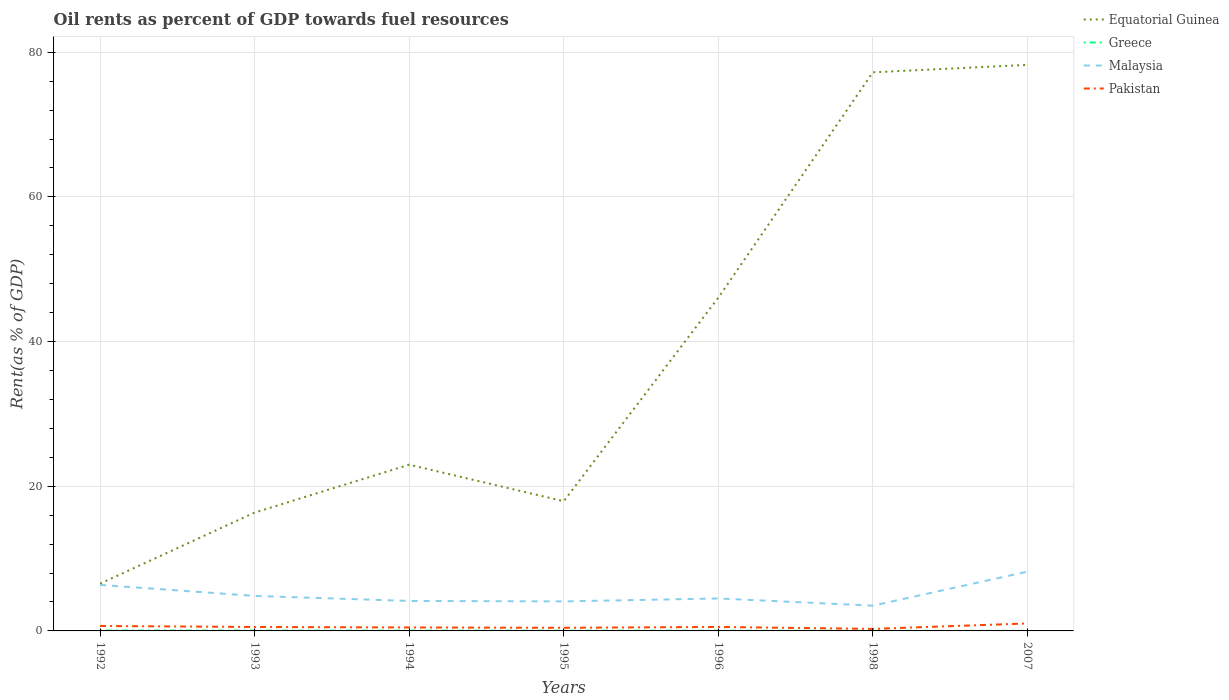Does the line corresponding to Malaysia intersect with the line corresponding to Equatorial Guinea?
Your response must be concise. No. Is the number of lines equal to the number of legend labels?
Make the answer very short. Yes. Across all years, what is the maximum oil rent in Equatorial Guinea?
Offer a terse response. 6.54. What is the total oil rent in Malaysia in the graph?
Your response must be concise. 1.52. What is the difference between the highest and the second highest oil rent in Greece?
Provide a succinct answer. 0.05. How many lines are there?
Provide a short and direct response. 4. Are the values on the major ticks of Y-axis written in scientific E-notation?
Offer a terse response. No. Does the graph contain any zero values?
Your answer should be very brief. No. Does the graph contain grids?
Ensure brevity in your answer.  Yes. Where does the legend appear in the graph?
Your answer should be very brief. Top right. How many legend labels are there?
Keep it short and to the point. 4. What is the title of the graph?
Keep it short and to the point. Oil rents as percent of GDP towards fuel resources. What is the label or title of the X-axis?
Your answer should be very brief. Years. What is the label or title of the Y-axis?
Provide a short and direct response. Rent(as % of GDP). What is the Rent(as % of GDP) in Equatorial Guinea in 1992?
Offer a very short reply. 6.54. What is the Rent(as % of GDP) in Greece in 1992?
Your answer should be very brief. 0.06. What is the Rent(as % of GDP) of Malaysia in 1992?
Provide a succinct answer. 6.36. What is the Rent(as % of GDP) of Pakistan in 1992?
Give a very brief answer. 0.68. What is the Rent(as % of GDP) of Equatorial Guinea in 1993?
Give a very brief answer. 16.36. What is the Rent(as % of GDP) of Greece in 1993?
Your answer should be very brief. 0.05. What is the Rent(as % of GDP) in Malaysia in 1993?
Offer a very short reply. 4.84. What is the Rent(as % of GDP) of Pakistan in 1993?
Give a very brief answer. 0.55. What is the Rent(as % of GDP) in Equatorial Guinea in 1994?
Your answer should be compact. 22.98. What is the Rent(as % of GDP) of Greece in 1994?
Give a very brief answer. 0.04. What is the Rent(as % of GDP) in Malaysia in 1994?
Give a very brief answer. 4.15. What is the Rent(as % of GDP) of Pakistan in 1994?
Offer a very short reply. 0.48. What is the Rent(as % of GDP) of Equatorial Guinea in 1995?
Give a very brief answer. 17.93. What is the Rent(as % of GDP) of Greece in 1995?
Provide a short and direct response. 0.03. What is the Rent(as % of GDP) in Malaysia in 1995?
Give a very brief answer. 4.08. What is the Rent(as % of GDP) of Pakistan in 1995?
Provide a short and direct response. 0.43. What is the Rent(as % of GDP) of Equatorial Guinea in 1996?
Your response must be concise. 46.07. What is the Rent(as % of GDP) in Greece in 1996?
Your answer should be very brief. 0.03. What is the Rent(as % of GDP) of Malaysia in 1996?
Keep it short and to the point. 4.49. What is the Rent(as % of GDP) of Pakistan in 1996?
Provide a succinct answer. 0.55. What is the Rent(as % of GDP) in Equatorial Guinea in 1998?
Offer a very short reply. 77.23. What is the Rent(as % of GDP) of Greece in 1998?
Make the answer very short. 0.01. What is the Rent(as % of GDP) in Malaysia in 1998?
Your answer should be very brief. 3.49. What is the Rent(as % of GDP) in Pakistan in 1998?
Offer a very short reply. 0.28. What is the Rent(as % of GDP) in Equatorial Guinea in 2007?
Provide a succinct answer. 78.25. What is the Rent(as % of GDP) in Greece in 2007?
Your answer should be very brief. 0.01. What is the Rent(as % of GDP) in Malaysia in 2007?
Make the answer very short. 8.19. What is the Rent(as % of GDP) of Pakistan in 2007?
Your response must be concise. 1.03. Across all years, what is the maximum Rent(as % of GDP) of Equatorial Guinea?
Ensure brevity in your answer.  78.25. Across all years, what is the maximum Rent(as % of GDP) of Greece?
Keep it short and to the point. 0.06. Across all years, what is the maximum Rent(as % of GDP) of Malaysia?
Your answer should be very brief. 8.19. Across all years, what is the maximum Rent(as % of GDP) of Pakistan?
Make the answer very short. 1.03. Across all years, what is the minimum Rent(as % of GDP) of Equatorial Guinea?
Give a very brief answer. 6.54. Across all years, what is the minimum Rent(as % of GDP) of Greece?
Offer a terse response. 0.01. Across all years, what is the minimum Rent(as % of GDP) in Malaysia?
Your answer should be compact. 3.49. Across all years, what is the minimum Rent(as % of GDP) of Pakistan?
Provide a succinct answer. 0.28. What is the total Rent(as % of GDP) of Equatorial Guinea in the graph?
Provide a short and direct response. 265.36. What is the total Rent(as % of GDP) in Greece in the graph?
Provide a succinct answer. 0.23. What is the total Rent(as % of GDP) in Malaysia in the graph?
Your answer should be compact. 35.6. What is the total Rent(as % of GDP) in Pakistan in the graph?
Your response must be concise. 4.01. What is the difference between the Rent(as % of GDP) of Equatorial Guinea in 1992 and that in 1993?
Make the answer very short. -9.83. What is the difference between the Rent(as % of GDP) of Greece in 1992 and that in 1993?
Keep it short and to the point. 0.01. What is the difference between the Rent(as % of GDP) in Malaysia in 1992 and that in 1993?
Your answer should be compact. 1.52. What is the difference between the Rent(as % of GDP) of Pakistan in 1992 and that in 1993?
Provide a short and direct response. 0.14. What is the difference between the Rent(as % of GDP) in Equatorial Guinea in 1992 and that in 1994?
Your answer should be compact. -16.44. What is the difference between the Rent(as % of GDP) of Greece in 1992 and that in 1994?
Make the answer very short. 0.02. What is the difference between the Rent(as % of GDP) of Malaysia in 1992 and that in 1994?
Offer a very short reply. 2.22. What is the difference between the Rent(as % of GDP) in Pakistan in 1992 and that in 1994?
Make the answer very short. 0.2. What is the difference between the Rent(as % of GDP) in Equatorial Guinea in 1992 and that in 1995?
Your answer should be compact. -11.39. What is the difference between the Rent(as % of GDP) of Greece in 1992 and that in 1995?
Ensure brevity in your answer.  0.03. What is the difference between the Rent(as % of GDP) of Malaysia in 1992 and that in 1995?
Offer a terse response. 2.28. What is the difference between the Rent(as % of GDP) in Pakistan in 1992 and that in 1995?
Offer a very short reply. 0.25. What is the difference between the Rent(as % of GDP) of Equatorial Guinea in 1992 and that in 1996?
Your answer should be compact. -39.53. What is the difference between the Rent(as % of GDP) in Greece in 1992 and that in 1996?
Provide a short and direct response. 0.03. What is the difference between the Rent(as % of GDP) in Malaysia in 1992 and that in 1996?
Keep it short and to the point. 1.88. What is the difference between the Rent(as % of GDP) in Pakistan in 1992 and that in 1996?
Provide a short and direct response. 0.13. What is the difference between the Rent(as % of GDP) in Equatorial Guinea in 1992 and that in 1998?
Provide a succinct answer. -70.69. What is the difference between the Rent(as % of GDP) of Greece in 1992 and that in 1998?
Your answer should be compact. 0.05. What is the difference between the Rent(as % of GDP) in Malaysia in 1992 and that in 1998?
Keep it short and to the point. 2.87. What is the difference between the Rent(as % of GDP) in Pakistan in 1992 and that in 1998?
Offer a very short reply. 0.4. What is the difference between the Rent(as % of GDP) in Equatorial Guinea in 1992 and that in 2007?
Your answer should be very brief. -71.72. What is the difference between the Rent(as % of GDP) of Greece in 1992 and that in 2007?
Keep it short and to the point. 0.05. What is the difference between the Rent(as % of GDP) of Malaysia in 1992 and that in 2007?
Your answer should be compact. -1.83. What is the difference between the Rent(as % of GDP) in Pakistan in 1992 and that in 2007?
Your answer should be compact. -0.35. What is the difference between the Rent(as % of GDP) in Equatorial Guinea in 1993 and that in 1994?
Your response must be concise. -6.62. What is the difference between the Rent(as % of GDP) of Greece in 1993 and that in 1994?
Provide a short and direct response. 0.01. What is the difference between the Rent(as % of GDP) in Malaysia in 1993 and that in 1994?
Provide a short and direct response. 0.69. What is the difference between the Rent(as % of GDP) in Pakistan in 1993 and that in 1994?
Give a very brief answer. 0.07. What is the difference between the Rent(as % of GDP) of Equatorial Guinea in 1993 and that in 1995?
Give a very brief answer. -1.57. What is the difference between the Rent(as % of GDP) of Greece in 1993 and that in 1995?
Keep it short and to the point. 0.01. What is the difference between the Rent(as % of GDP) in Malaysia in 1993 and that in 1995?
Your response must be concise. 0.76. What is the difference between the Rent(as % of GDP) in Pakistan in 1993 and that in 1995?
Offer a terse response. 0.11. What is the difference between the Rent(as % of GDP) of Equatorial Guinea in 1993 and that in 1996?
Provide a short and direct response. -29.7. What is the difference between the Rent(as % of GDP) in Greece in 1993 and that in 1996?
Offer a very short reply. 0.01. What is the difference between the Rent(as % of GDP) in Malaysia in 1993 and that in 1996?
Ensure brevity in your answer.  0.35. What is the difference between the Rent(as % of GDP) in Pakistan in 1993 and that in 1996?
Your response must be concise. -0. What is the difference between the Rent(as % of GDP) in Equatorial Guinea in 1993 and that in 1998?
Your answer should be compact. -60.86. What is the difference between the Rent(as % of GDP) of Greece in 1993 and that in 1998?
Provide a short and direct response. 0.03. What is the difference between the Rent(as % of GDP) in Malaysia in 1993 and that in 1998?
Offer a very short reply. 1.35. What is the difference between the Rent(as % of GDP) of Pakistan in 1993 and that in 1998?
Provide a short and direct response. 0.27. What is the difference between the Rent(as % of GDP) in Equatorial Guinea in 1993 and that in 2007?
Your answer should be very brief. -61.89. What is the difference between the Rent(as % of GDP) of Greece in 1993 and that in 2007?
Make the answer very short. 0.04. What is the difference between the Rent(as % of GDP) of Malaysia in 1993 and that in 2007?
Your answer should be very brief. -3.36. What is the difference between the Rent(as % of GDP) of Pakistan in 1993 and that in 2007?
Ensure brevity in your answer.  -0.49. What is the difference between the Rent(as % of GDP) in Equatorial Guinea in 1994 and that in 1995?
Offer a very short reply. 5.05. What is the difference between the Rent(as % of GDP) in Greece in 1994 and that in 1995?
Your response must be concise. 0.01. What is the difference between the Rent(as % of GDP) of Malaysia in 1994 and that in 1995?
Your response must be concise. 0.07. What is the difference between the Rent(as % of GDP) of Pakistan in 1994 and that in 1995?
Give a very brief answer. 0.04. What is the difference between the Rent(as % of GDP) of Equatorial Guinea in 1994 and that in 1996?
Your response must be concise. -23.08. What is the difference between the Rent(as % of GDP) of Greece in 1994 and that in 1996?
Your answer should be very brief. 0.01. What is the difference between the Rent(as % of GDP) in Malaysia in 1994 and that in 1996?
Provide a short and direct response. -0.34. What is the difference between the Rent(as % of GDP) of Pakistan in 1994 and that in 1996?
Offer a terse response. -0.07. What is the difference between the Rent(as % of GDP) in Equatorial Guinea in 1994 and that in 1998?
Provide a succinct answer. -54.25. What is the difference between the Rent(as % of GDP) of Greece in 1994 and that in 1998?
Make the answer very short. 0.02. What is the difference between the Rent(as % of GDP) of Malaysia in 1994 and that in 1998?
Your answer should be compact. 0.65. What is the difference between the Rent(as % of GDP) of Pakistan in 1994 and that in 1998?
Your answer should be very brief. 0.2. What is the difference between the Rent(as % of GDP) of Equatorial Guinea in 1994 and that in 2007?
Provide a succinct answer. -55.27. What is the difference between the Rent(as % of GDP) in Greece in 1994 and that in 2007?
Your answer should be compact. 0.03. What is the difference between the Rent(as % of GDP) in Malaysia in 1994 and that in 2007?
Your answer should be very brief. -4.05. What is the difference between the Rent(as % of GDP) in Pakistan in 1994 and that in 2007?
Your answer should be very brief. -0.56. What is the difference between the Rent(as % of GDP) of Equatorial Guinea in 1995 and that in 1996?
Provide a short and direct response. -28.14. What is the difference between the Rent(as % of GDP) of Greece in 1995 and that in 1996?
Offer a very short reply. -0. What is the difference between the Rent(as % of GDP) of Malaysia in 1995 and that in 1996?
Ensure brevity in your answer.  -0.41. What is the difference between the Rent(as % of GDP) of Pakistan in 1995 and that in 1996?
Your answer should be compact. -0.12. What is the difference between the Rent(as % of GDP) of Equatorial Guinea in 1995 and that in 1998?
Provide a succinct answer. -59.3. What is the difference between the Rent(as % of GDP) of Greece in 1995 and that in 1998?
Offer a very short reply. 0.02. What is the difference between the Rent(as % of GDP) of Malaysia in 1995 and that in 1998?
Provide a succinct answer. 0.59. What is the difference between the Rent(as % of GDP) of Pakistan in 1995 and that in 1998?
Your response must be concise. 0.16. What is the difference between the Rent(as % of GDP) in Equatorial Guinea in 1995 and that in 2007?
Offer a terse response. -60.32. What is the difference between the Rent(as % of GDP) in Greece in 1995 and that in 2007?
Your answer should be very brief. 0.02. What is the difference between the Rent(as % of GDP) in Malaysia in 1995 and that in 2007?
Provide a short and direct response. -4.11. What is the difference between the Rent(as % of GDP) in Pakistan in 1995 and that in 2007?
Offer a terse response. -0.6. What is the difference between the Rent(as % of GDP) of Equatorial Guinea in 1996 and that in 1998?
Your response must be concise. -31.16. What is the difference between the Rent(as % of GDP) of Greece in 1996 and that in 1998?
Provide a succinct answer. 0.02. What is the difference between the Rent(as % of GDP) of Pakistan in 1996 and that in 1998?
Ensure brevity in your answer.  0.27. What is the difference between the Rent(as % of GDP) in Equatorial Guinea in 1996 and that in 2007?
Offer a very short reply. -32.19. What is the difference between the Rent(as % of GDP) of Greece in 1996 and that in 2007?
Provide a succinct answer. 0.02. What is the difference between the Rent(as % of GDP) in Malaysia in 1996 and that in 2007?
Your answer should be very brief. -3.71. What is the difference between the Rent(as % of GDP) of Pakistan in 1996 and that in 2007?
Make the answer very short. -0.48. What is the difference between the Rent(as % of GDP) in Equatorial Guinea in 1998 and that in 2007?
Your response must be concise. -1.03. What is the difference between the Rent(as % of GDP) in Greece in 1998 and that in 2007?
Provide a succinct answer. 0. What is the difference between the Rent(as % of GDP) in Malaysia in 1998 and that in 2007?
Offer a terse response. -4.7. What is the difference between the Rent(as % of GDP) in Pakistan in 1998 and that in 2007?
Your response must be concise. -0.76. What is the difference between the Rent(as % of GDP) in Equatorial Guinea in 1992 and the Rent(as % of GDP) in Greece in 1993?
Keep it short and to the point. 6.49. What is the difference between the Rent(as % of GDP) of Equatorial Guinea in 1992 and the Rent(as % of GDP) of Malaysia in 1993?
Offer a very short reply. 1.7. What is the difference between the Rent(as % of GDP) of Equatorial Guinea in 1992 and the Rent(as % of GDP) of Pakistan in 1993?
Your answer should be very brief. 5.99. What is the difference between the Rent(as % of GDP) in Greece in 1992 and the Rent(as % of GDP) in Malaysia in 1993?
Provide a short and direct response. -4.78. What is the difference between the Rent(as % of GDP) in Greece in 1992 and the Rent(as % of GDP) in Pakistan in 1993?
Offer a terse response. -0.49. What is the difference between the Rent(as % of GDP) of Malaysia in 1992 and the Rent(as % of GDP) of Pakistan in 1993?
Your answer should be compact. 5.82. What is the difference between the Rent(as % of GDP) in Equatorial Guinea in 1992 and the Rent(as % of GDP) in Greece in 1994?
Ensure brevity in your answer.  6.5. What is the difference between the Rent(as % of GDP) of Equatorial Guinea in 1992 and the Rent(as % of GDP) of Malaysia in 1994?
Provide a short and direct response. 2.39. What is the difference between the Rent(as % of GDP) of Equatorial Guinea in 1992 and the Rent(as % of GDP) of Pakistan in 1994?
Give a very brief answer. 6.06. What is the difference between the Rent(as % of GDP) of Greece in 1992 and the Rent(as % of GDP) of Malaysia in 1994?
Provide a short and direct response. -4.08. What is the difference between the Rent(as % of GDP) in Greece in 1992 and the Rent(as % of GDP) in Pakistan in 1994?
Keep it short and to the point. -0.42. What is the difference between the Rent(as % of GDP) of Malaysia in 1992 and the Rent(as % of GDP) of Pakistan in 1994?
Offer a very short reply. 5.88. What is the difference between the Rent(as % of GDP) of Equatorial Guinea in 1992 and the Rent(as % of GDP) of Greece in 1995?
Make the answer very short. 6.51. What is the difference between the Rent(as % of GDP) in Equatorial Guinea in 1992 and the Rent(as % of GDP) in Malaysia in 1995?
Provide a succinct answer. 2.46. What is the difference between the Rent(as % of GDP) of Equatorial Guinea in 1992 and the Rent(as % of GDP) of Pakistan in 1995?
Offer a very short reply. 6.1. What is the difference between the Rent(as % of GDP) of Greece in 1992 and the Rent(as % of GDP) of Malaysia in 1995?
Make the answer very short. -4.02. What is the difference between the Rent(as % of GDP) in Greece in 1992 and the Rent(as % of GDP) in Pakistan in 1995?
Ensure brevity in your answer.  -0.37. What is the difference between the Rent(as % of GDP) of Malaysia in 1992 and the Rent(as % of GDP) of Pakistan in 1995?
Keep it short and to the point. 5.93. What is the difference between the Rent(as % of GDP) of Equatorial Guinea in 1992 and the Rent(as % of GDP) of Greece in 1996?
Your answer should be very brief. 6.5. What is the difference between the Rent(as % of GDP) in Equatorial Guinea in 1992 and the Rent(as % of GDP) in Malaysia in 1996?
Provide a succinct answer. 2.05. What is the difference between the Rent(as % of GDP) of Equatorial Guinea in 1992 and the Rent(as % of GDP) of Pakistan in 1996?
Provide a succinct answer. 5.99. What is the difference between the Rent(as % of GDP) in Greece in 1992 and the Rent(as % of GDP) in Malaysia in 1996?
Your answer should be very brief. -4.43. What is the difference between the Rent(as % of GDP) of Greece in 1992 and the Rent(as % of GDP) of Pakistan in 1996?
Make the answer very short. -0.49. What is the difference between the Rent(as % of GDP) in Malaysia in 1992 and the Rent(as % of GDP) in Pakistan in 1996?
Provide a succinct answer. 5.81. What is the difference between the Rent(as % of GDP) of Equatorial Guinea in 1992 and the Rent(as % of GDP) of Greece in 1998?
Your response must be concise. 6.52. What is the difference between the Rent(as % of GDP) of Equatorial Guinea in 1992 and the Rent(as % of GDP) of Malaysia in 1998?
Your response must be concise. 3.04. What is the difference between the Rent(as % of GDP) of Equatorial Guinea in 1992 and the Rent(as % of GDP) of Pakistan in 1998?
Your response must be concise. 6.26. What is the difference between the Rent(as % of GDP) in Greece in 1992 and the Rent(as % of GDP) in Malaysia in 1998?
Provide a short and direct response. -3.43. What is the difference between the Rent(as % of GDP) of Greece in 1992 and the Rent(as % of GDP) of Pakistan in 1998?
Give a very brief answer. -0.22. What is the difference between the Rent(as % of GDP) in Malaysia in 1992 and the Rent(as % of GDP) in Pakistan in 1998?
Provide a succinct answer. 6.09. What is the difference between the Rent(as % of GDP) in Equatorial Guinea in 1992 and the Rent(as % of GDP) in Greece in 2007?
Provide a short and direct response. 6.53. What is the difference between the Rent(as % of GDP) in Equatorial Guinea in 1992 and the Rent(as % of GDP) in Malaysia in 2007?
Make the answer very short. -1.66. What is the difference between the Rent(as % of GDP) in Equatorial Guinea in 1992 and the Rent(as % of GDP) in Pakistan in 2007?
Offer a terse response. 5.5. What is the difference between the Rent(as % of GDP) of Greece in 1992 and the Rent(as % of GDP) of Malaysia in 2007?
Your answer should be compact. -8.13. What is the difference between the Rent(as % of GDP) of Greece in 1992 and the Rent(as % of GDP) of Pakistan in 2007?
Offer a very short reply. -0.97. What is the difference between the Rent(as % of GDP) in Malaysia in 1992 and the Rent(as % of GDP) in Pakistan in 2007?
Give a very brief answer. 5.33. What is the difference between the Rent(as % of GDP) in Equatorial Guinea in 1993 and the Rent(as % of GDP) in Greece in 1994?
Ensure brevity in your answer.  16.33. What is the difference between the Rent(as % of GDP) in Equatorial Guinea in 1993 and the Rent(as % of GDP) in Malaysia in 1994?
Provide a short and direct response. 12.22. What is the difference between the Rent(as % of GDP) of Equatorial Guinea in 1993 and the Rent(as % of GDP) of Pakistan in 1994?
Offer a terse response. 15.88. What is the difference between the Rent(as % of GDP) of Greece in 1993 and the Rent(as % of GDP) of Malaysia in 1994?
Provide a succinct answer. -4.1. What is the difference between the Rent(as % of GDP) in Greece in 1993 and the Rent(as % of GDP) in Pakistan in 1994?
Ensure brevity in your answer.  -0.43. What is the difference between the Rent(as % of GDP) in Malaysia in 1993 and the Rent(as % of GDP) in Pakistan in 1994?
Offer a very short reply. 4.36. What is the difference between the Rent(as % of GDP) in Equatorial Guinea in 1993 and the Rent(as % of GDP) in Greece in 1995?
Keep it short and to the point. 16.33. What is the difference between the Rent(as % of GDP) of Equatorial Guinea in 1993 and the Rent(as % of GDP) of Malaysia in 1995?
Provide a succinct answer. 12.28. What is the difference between the Rent(as % of GDP) in Equatorial Guinea in 1993 and the Rent(as % of GDP) in Pakistan in 1995?
Provide a succinct answer. 15.93. What is the difference between the Rent(as % of GDP) of Greece in 1993 and the Rent(as % of GDP) of Malaysia in 1995?
Provide a short and direct response. -4.03. What is the difference between the Rent(as % of GDP) in Greece in 1993 and the Rent(as % of GDP) in Pakistan in 1995?
Provide a succinct answer. -0.39. What is the difference between the Rent(as % of GDP) in Malaysia in 1993 and the Rent(as % of GDP) in Pakistan in 1995?
Offer a terse response. 4.41. What is the difference between the Rent(as % of GDP) in Equatorial Guinea in 1993 and the Rent(as % of GDP) in Greece in 1996?
Make the answer very short. 16.33. What is the difference between the Rent(as % of GDP) of Equatorial Guinea in 1993 and the Rent(as % of GDP) of Malaysia in 1996?
Give a very brief answer. 11.87. What is the difference between the Rent(as % of GDP) in Equatorial Guinea in 1993 and the Rent(as % of GDP) in Pakistan in 1996?
Give a very brief answer. 15.81. What is the difference between the Rent(as % of GDP) in Greece in 1993 and the Rent(as % of GDP) in Malaysia in 1996?
Ensure brevity in your answer.  -4.44. What is the difference between the Rent(as % of GDP) in Greece in 1993 and the Rent(as % of GDP) in Pakistan in 1996?
Ensure brevity in your answer.  -0.51. What is the difference between the Rent(as % of GDP) in Malaysia in 1993 and the Rent(as % of GDP) in Pakistan in 1996?
Provide a succinct answer. 4.29. What is the difference between the Rent(as % of GDP) in Equatorial Guinea in 1993 and the Rent(as % of GDP) in Greece in 1998?
Make the answer very short. 16.35. What is the difference between the Rent(as % of GDP) of Equatorial Guinea in 1993 and the Rent(as % of GDP) of Malaysia in 1998?
Give a very brief answer. 12.87. What is the difference between the Rent(as % of GDP) of Equatorial Guinea in 1993 and the Rent(as % of GDP) of Pakistan in 1998?
Provide a succinct answer. 16.08. What is the difference between the Rent(as % of GDP) in Greece in 1993 and the Rent(as % of GDP) in Malaysia in 1998?
Ensure brevity in your answer.  -3.45. What is the difference between the Rent(as % of GDP) of Greece in 1993 and the Rent(as % of GDP) of Pakistan in 1998?
Give a very brief answer. -0.23. What is the difference between the Rent(as % of GDP) in Malaysia in 1993 and the Rent(as % of GDP) in Pakistan in 1998?
Keep it short and to the point. 4.56. What is the difference between the Rent(as % of GDP) of Equatorial Guinea in 1993 and the Rent(as % of GDP) of Greece in 2007?
Your answer should be very brief. 16.35. What is the difference between the Rent(as % of GDP) of Equatorial Guinea in 1993 and the Rent(as % of GDP) of Malaysia in 2007?
Provide a succinct answer. 8.17. What is the difference between the Rent(as % of GDP) of Equatorial Guinea in 1993 and the Rent(as % of GDP) of Pakistan in 2007?
Your answer should be compact. 15.33. What is the difference between the Rent(as % of GDP) in Greece in 1993 and the Rent(as % of GDP) in Malaysia in 2007?
Your answer should be very brief. -8.15. What is the difference between the Rent(as % of GDP) of Greece in 1993 and the Rent(as % of GDP) of Pakistan in 2007?
Make the answer very short. -0.99. What is the difference between the Rent(as % of GDP) in Malaysia in 1993 and the Rent(as % of GDP) in Pakistan in 2007?
Ensure brevity in your answer.  3.8. What is the difference between the Rent(as % of GDP) in Equatorial Guinea in 1994 and the Rent(as % of GDP) in Greece in 1995?
Offer a very short reply. 22.95. What is the difference between the Rent(as % of GDP) in Equatorial Guinea in 1994 and the Rent(as % of GDP) in Malaysia in 1995?
Your response must be concise. 18.9. What is the difference between the Rent(as % of GDP) of Equatorial Guinea in 1994 and the Rent(as % of GDP) of Pakistan in 1995?
Keep it short and to the point. 22.55. What is the difference between the Rent(as % of GDP) in Greece in 1994 and the Rent(as % of GDP) in Malaysia in 1995?
Offer a terse response. -4.04. What is the difference between the Rent(as % of GDP) of Greece in 1994 and the Rent(as % of GDP) of Pakistan in 1995?
Offer a terse response. -0.4. What is the difference between the Rent(as % of GDP) of Malaysia in 1994 and the Rent(as % of GDP) of Pakistan in 1995?
Provide a succinct answer. 3.71. What is the difference between the Rent(as % of GDP) in Equatorial Guinea in 1994 and the Rent(as % of GDP) in Greece in 1996?
Provide a succinct answer. 22.95. What is the difference between the Rent(as % of GDP) of Equatorial Guinea in 1994 and the Rent(as % of GDP) of Malaysia in 1996?
Offer a very short reply. 18.49. What is the difference between the Rent(as % of GDP) in Equatorial Guinea in 1994 and the Rent(as % of GDP) in Pakistan in 1996?
Your answer should be compact. 22.43. What is the difference between the Rent(as % of GDP) in Greece in 1994 and the Rent(as % of GDP) in Malaysia in 1996?
Provide a short and direct response. -4.45. What is the difference between the Rent(as % of GDP) in Greece in 1994 and the Rent(as % of GDP) in Pakistan in 1996?
Provide a succinct answer. -0.51. What is the difference between the Rent(as % of GDP) of Malaysia in 1994 and the Rent(as % of GDP) of Pakistan in 1996?
Provide a succinct answer. 3.59. What is the difference between the Rent(as % of GDP) in Equatorial Guinea in 1994 and the Rent(as % of GDP) in Greece in 1998?
Your answer should be very brief. 22.97. What is the difference between the Rent(as % of GDP) of Equatorial Guinea in 1994 and the Rent(as % of GDP) of Malaysia in 1998?
Provide a short and direct response. 19.49. What is the difference between the Rent(as % of GDP) of Equatorial Guinea in 1994 and the Rent(as % of GDP) of Pakistan in 1998?
Offer a terse response. 22.7. What is the difference between the Rent(as % of GDP) of Greece in 1994 and the Rent(as % of GDP) of Malaysia in 1998?
Offer a terse response. -3.45. What is the difference between the Rent(as % of GDP) of Greece in 1994 and the Rent(as % of GDP) of Pakistan in 1998?
Your answer should be very brief. -0.24. What is the difference between the Rent(as % of GDP) of Malaysia in 1994 and the Rent(as % of GDP) of Pakistan in 1998?
Provide a succinct answer. 3.87. What is the difference between the Rent(as % of GDP) of Equatorial Guinea in 1994 and the Rent(as % of GDP) of Greece in 2007?
Your response must be concise. 22.97. What is the difference between the Rent(as % of GDP) in Equatorial Guinea in 1994 and the Rent(as % of GDP) in Malaysia in 2007?
Offer a terse response. 14.79. What is the difference between the Rent(as % of GDP) of Equatorial Guinea in 1994 and the Rent(as % of GDP) of Pakistan in 2007?
Your answer should be compact. 21.95. What is the difference between the Rent(as % of GDP) of Greece in 1994 and the Rent(as % of GDP) of Malaysia in 2007?
Offer a terse response. -8.16. What is the difference between the Rent(as % of GDP) of Greece in 1994 and the Rent(as % of GDP) of Pakistan in 2007?
Your answer should be very brief. -1. What is the difference between the Rent(as % of GDP) of Malaysia in 1994 and the Rent(as % of GDP) of Pakistan in 2007?
Offer a terse response. 3.11. What is the difference between the Rent(as % of GDP) of Equatorial Guinea in 1995 and the Rent(as % of GDP) of Greece in 1996?
Give a very brief answer. 17.9. What is the difference between the Rent(as % of GDP) in Equatorial Guinea in 1995 and the Rent(as % of GDP) in Malaysia in 1996?
Your answer should be compact. 13.44. What is the difference between the Rent(as % of GDP) of Equatorial Guinea in 1995 and the Rent(as % of GDP) of Pakistan in 1996?
Your answer should be compact. 17.38. What is the difference between the Rent(as % of GDP) of Greece in 1995 and the Rent(as % of GDP) of Malaysia in 1996?
Give a very brief answer. -4.46. What is the difference between the Rent(as % of GDP) of Greece in 1995 and the Rent(as % of GDP) of Pakistan in 1996?
Your response must be concise. -0.52. What is the difference between the Rent(as % of GDP) of Malaysia in 1995 and the Rent(as % of GDP) of Pakistan in 1996?
Provide a succinct answer. 3.53. What is the difference between the Rent(as % of GDP) in Equatorial Guinea in 1995 and the Rent(as % of GDP) in Greece in 1998?
Your answer should be very brief. 17.92. What is the difference between the Rent(as % of GDP) of Equatorial Guinea in 1995 and the Rent(as % of GDP) of Malaysia in 1998?
Offer a terse response. 14.44. What is the difference between the Rent(as % of GDP) in Equatorial Guinea in 1995 and the Rent(as % of GDP) in Pakistan in 1998?
Your response must be concise. 17.65. What is the difference between the Rent(as % of GDP) of Greece in 1995 and the Rent(as % of GDP) of Malaysia in 1998?
Give a very brief answer. -3.46. What is the difference between the Rent(as % of GDP) of Greece in 1995 and the Rent(as % of GDP) of Pakistan in 1998?
Offer a terse response. -0.25. What is the difference between the Rent(as % of GDP) in Malaysia in 1995 and the Rent(as % of GDP) in Pakistan in 1998?
Provide a succinct answer. 3.8. What is the difference between the Rent(as % of GDP) in Equatorial Guinea in 1995 and the Rent(as % of GDP) in Greece in 2007?
Your answer should be compact. 17.92. What is the difference between the Rent(as % of GDP) in Equatorial Guinea in 1995 and the Rent(as % of GDP) in Malaysia in 2007?
Your answer should be compact. 9.74. What is the difference between the Rent(as % of GDP) of Equatorial Guinea in 1995 and the Rent(as % of GDP) of Pakistan in 2007?
Your response must be concise. 16.9. What is the difference between the Rent(as % of GDP) of Greece in 1995 and the Rent(as % of GDP) of Malaysia in 2007?
Your answer should be compact. -8.16. What is the difference between the Rent(as % of GDP) in Greece in 1995 and the Rent(as % of GDP) in Pakistan in 2007?
Provide a short and direct response. -1. What is the difference between the Rent(as % of GDP) of Malaysia in 1995 and the Rent(as % of GDP) of Pakistan in 2007?
Give a very brief answer. 3.04. What is the difference between the Rent(as % of GDP) in Equatorial Guinea in 1996 and the Rent(as % of GDP) in Greece in 1998?
Make the answer very short. 46.05. What is the difference between the Rent(as % of GDP) in Equatorial Guinea in 1996 and the Rent(as % of GDP) in Malaysia in 1998?
Offer a terse response. 42.57. What is the difference between the Rent(as % of GDP) of Equatorial Guinea in 1996 and the Rent(as % of GDP) of Pakistan in 1998?
Give a very brief answer. 45.79. What is the difference between the Rent(as % of GDP) in Greece in 1996 and the Rent(as % of GDP) in Malaysia in 1998?
Your response must be concise. -3.46. What is the difference between the Rent(as % of GDP) of Greece in 1996 and the Rent(as % of GDP) of Pakistan in 1998?
Keep it short and to the point. -0.25. What is the difference between the Rent(as % of GDP) in Malaysia in 1996 and the Rent(as % of GDP) in Pakistan in 1998?
Provide a succinct answer. 4.21. What is the difference between the Rent(as % of GDP) of Equatorial Guinea in 1996 and the Rent(as % of GDP) of Greece in 2007?
Provide a succinct answer. 46.06. What is the difference between the Rent(as % of GDP) in Equatorial Guinea in 1996 and the Rent(as % of GDP) in Malaysia in 2007?
Your answer should be compact. 37.87. What is the difference between the Rent(as % of GDP) of Equatorial Guinea in 1996 and the Rent(as % of GDP) of Pakistan in 2007?
Offer a very short reply. 45.03. What is the difference between the Rent(as % of GDP) of Greece in 1996 and the Rent(as % of GDP) of Malaysia in 2007?
Provide a succinct answer. -8.16. What is the difference between the Rent(as % of GDP) of Greece in 1996 and the Rent(as % of GDP) of Pakistan in 2007?
Give a very brief answer. -1. What is the difference between the Rent(as % of GDP) of Malaysia in 1996 and the Rent(as % of GDP) of Pakistan in 2007?
Your answer should be very brief. 3.45. What is the difference between the Rent(as % of GDP) of Equatorial Guinea in 1998 and the Rent(as % of GDP) of Greece in 2007?
Provide a short and direct response. 77.22. What is the difference between the Rent(as % of GDP) in Equatorial Guinea in 1998 and the Rent(as % of GDP) in Malaysia in 2007?
Offer a very short reply. 69.03. What is the difference between the Rent(as % of GDP) of Equatorial Guinea in 1998 and the Rent(as % of GDP) of Pakistan in 2007?
Your answer should be very brief. 76.19. What is the difference between the Rent(as % of GDP) in Greece in 1998 and the Rent(as % of GDP) in Malaysia in 2007?
Provide a short and direct response. -8.18. What is the difference between the Rent(as % of GDP) in Greece in 1998 and the Rent(as % of GDP) in Pakistan in 2007?
Give a very brief answer. -1.02. What is the difference between the Rent(as % of GDP) in Malaysia in 1998 and the Rent(as % of GDP) in Pakistan in 2007?
Provide a short and direct response. 2.46. What is the average Rent(as % of GDP) in Equatorial Guinea per year?
Your response must be concise. 37.91. What is the average Rent(as % of GDP) in Greece per year?
Provide a succinct answer. 0.03. What is the average Rent(as % of GDP) of Malaysia per year?
Keep it short and to the point. 5.09. What is the average Rent(as % of GDP) in Pakistan per year?
Offer a very short reply. 0.57. In the year 1992, what is the difference between the Rent(as % of GDP) of Equatorial Guinea and Rent(as % of GDP) of Greece?
Your response must be concise. 6.48. In the year 1992, what is the difference between the Rent(as % of GDP) of Equatorial Guinea and Rent(as % of GDP) of Malaysia?
Make the answer very short. 0.17. In the year 1992, what is the difference between the Rent(as % of GDP) in Equatorial Guinea and Rent(as % of GDP) in Pakistan?
Offer a terse response. 5.85. In the year 1992, what is the difference between the Rent(as % of GDP) in Greece and Rent(as % of GDP) in Malaysia?
Your response must be concise. -6.3. In the year 1992, what is the difference between the Rent(as % of GDP) in Greece and Rent(as % of GDP) in Pakistan?
Offer a terse response. -0.62. In the year 1992, what is the difference between the Rent(as % of GDP) in Malaysia and Rent(as % of GDP) in Pakistan?
Make the answer very short. 5.68. In the year 1993, what is the difference between the Rent(as % of GDP) of Equatorial Guinea and Rent(as % of GDP) of Greece?
Make the answer very short. 16.32. In the year 1993, what is the difference between the Rent(as % of GDP) of Equatorial Guinea and Rent(as % of GDP) of Malaysia?
Offer a very short reply. 11.52. In the year 1993, what is the difference between the Rent(as % of GDP) in Equatorial Guinea and Rent(as % of GDP) in Pakistan?
Offer a terse response. 15.82. In the year 1993, what is the difference between the Rent(as % of GDP) of Greece and Rent(as % of GDP) of Malaysia?
Make the answer very short. -4.79. In the year 1993, what is the difference between the Rent(as % of GDP) of Greece and Rent(as % of GDP) of Pakistan?
Keep it short and to the point. -0.5. In the year 1993, what is the difference between the Rent(as % of GDP) in Malaysia and Rent(as % of GDP) in Pakistan?
Offer a terse response. 4.29. In the year 1994, what is the difference between the Rent(as % of GDP) of Equatorial Guinea and Rent(as % of GDP) of Greece?
Keep it short and to the point. 22.94. In the year 1994, what is the difference between the Rent(as % of GDP) of Equatorial Guinea and Rent(as % of GDP) of Malaysia?
Make the answer very short. 18.84. In the year 1994, what is the difference between the Rent(as % of GDP) of Equatorial Guinea and Rent(as % of GDP) of Pakistan?
Your response must be concise. 22.5. In the year 1994, what is the difference between the Rent(as % of GDP) of Greece and Rent(as % of GDP) of Malaysia?
Your answer should be very brief. -4.11. In the year 1994, what is the difference between the Rent(as % of GDP) in Greece and Rent(as % of GDP) in Pakistan?
Your answer should be very brief. -0.44. In the year 1994, what is the difference between the Rent(as % of GDP) in Malaysia and Rent(as % of GDP) in Pakistan?
Make the answer very short. 3.67. In the year 1995, what is the difference between the Rent(as % of GDP) of Equatorial Guinea and Rent(as % of GDP) of Greece?
Give a very brief answer. 17.9. In the year 1995, what is the difference between the Rent(as % of GDP) of Equatorial Guinea and Rent(as % of GDP) of Malaysia?
Give a very brief answer. 13.85. In the year 1995, what is the difference between the Rent(as % of GDP) of Equatorial Guinea and Rent(as % of GDP) of Pakistan?
Make the answer very short. 17.5. In the year 1995, what is the difference between the Rent(as % of GDP) in Greece and Rent(as % of GDP) in Malaysia?
Make the answer very short. -4.05. In the year 1995, what is the difference between the Rent(as % of GDP) of Greece and Rent(as % of GDP) of Pakistan?
Make the answer very short. -0.4. In the year 1995, what is the difference between the Rent(as % of GDP) of Malaysia and Rent(as % of GDP) of Pakistan?
Your answer should be very brief. 3.65. In the year 1996, what is the difference between the Rent(as % of GDP) of Equatorial Guinea and Rent(as % of GDP) of Greece?
Keep it short and to the point. 46.03. In the year 1996, what is the difference between the Rent(as % of GDP) of Equatorial Guinea and Rent(as % of GDP) of Malaysia?
Give a very brief answer. 41.58. In the year 1996, what is the difference between the Rent(as % of GDP) in Equatorial Guinea and Rent(as % of GDP) in Pakistan?
Provide a succinct answer. 45.51. In the year 1996, what is the difference between the Rent(as % of GDP) of Greece and Rent(as % of GDP) of Malaysia?
Provide a short and direct response. -4.46. In the year 1996, what is the difference between the Rent(as % of GDP) of Greece and Rent(as % of GDP) of Pakistan?
Keep it short and to the point. -0.52. In the year 1996, what is the difference between the Rent(as % of GDP) of Malaysia and Rent(as % of GDP) of Pakistan?
Keep it short and to the point. 3.94. In the year 1998, what is the difference between the Rent(as % of GDP) in Equatorial Guinea and Rent(as % of GDP) in Greece?
Keep it short and to the point. 77.21. In the year 1998, what is the difference between the Rent(as % of GDP) in Equatorial Guinea and Rent(as % of GDP) in Malaysia?
Offer a very short reply. 73.73. In the year 1998, what is the difference between the Rent(as % of GDP) in Equatorial Guinea and Rent(as % of GDP) in Pakistan?
Provide a short and direct response. 76.95. In the year 1998, what is the difference between the Rent(as % of GDP) of Greece and Rent(as % of GDP) of Malaysia?
Offer a terse response. -3.48. In the year 1998, what is the difference between the Rent(as % of GDP) of Greece and Rent(as % of GDP) of Pakistan?
Make the answer very short. -0.26. In the year 1998, what is the difference between the Rent(as % of GDP) in Malaysia and Rent(as % of GDP) in Pakistan?
Ensure brevity in your answer.  3.21. In the year 2007, what is the difference between the Rent(as % of GDP) in Equatorial Guinea and Rent(as % of GDP) in Greece?
Offer a very short reply. 78.25. In the year 2007, what is the difference between the Rent(as % of GDP) of Equatorial Guinea and Rent(as % of GDP) of Malaysia?
Ensure brevity in your answer.  70.06. In the year 2007, what is the difference between the Rent(as % of GDP) in Equatorial Guinea and Rent(as % of GDP) in Pakistan?
Make the answer very short. 77.22. In the year 2007, what is the difference between the Rent(as % of GDP) in Greece and Rent(as % of GDP) in Malaysia?
Your answer should be compact. -8.19. In the year 2007, what is the difference between the Rent(as % of GDP) in Greece and Rent(as % of GDP) in Pakistan?
Your answer should be very brief. -1.03. In the year 2007, what is the difference between the Rent(as % of GDP) in Malaysia and Rent(as % of GDP) in Pakistan?
Offer a terse response. 7.16. What is the ratio of the Rent(as % of GDP) in Equatorial Guinea in 1992 to that in 1993?
Your answer should be compact. 0.4. What is the ratio of the Rent(as % of GDP) in Greece in 1992 to that in 1993?
Provide a succinct answer. 1.32. What is the ratio of the Rent(as % of GDP) of Malaysia in 1992 to that in 1993?
Ensure brevity in your answer.  1.32. What is the ratio of the Rent(as % of GDP) in Pakistan in 1992 to that in 1993?
Make the answer very short. 1.25. What is the ratio of the Rent(as % of GDP) of Equatorial Guinea in 1992 to that in 1994?
Offer a terse response. 0.28. What is the ratio of the Rent(as % of GDP) in Greece in 1992 to that in 1994?
Provide a short and direct response. 1.61. What is the ratio of the Rent(as % of GDP) in Malaysia in 1992 to that in 1994?
Your response must be concise. 1.54. What is the ratio of the Rent(as % of GDP) of Pakistan in 1992 to that in 1994?
Offer a terse response. 1.43. What is the ratio of the Rent(as % of GDP) of Equatorial Guinea in 1992 to that in 1995?
Your answer should be compact. 0.36. What is the ratio of the Rent(as % of GDP) of Greece in 1992 to that in 1995?
Your answer should be compact. 1.94. What is the ratio of the Rent(as % of GDP) in Malaysia in 1992 to that in 1995?
Ensure brevity in your answer.  1.56. What is the ratio of the Rent(as % of GDP) in Pakistan in 1992 to that in 1995?
Ensure brevity in your answer.  1.57. What is the ratio of the Rent(as % of GDP) of Equatorial Guinea in 1992 to that in 1996?
Your response must be concise. 0.14. What is the ratio of the Rent(as % of GDP) of Greece in 1992 to that in 1996?
Keep it short and to the point. 1.87. What is the ratio of the Rent(as % of GDP) in Malaysia in 1992 to that in 1996?
Keep it short and to the point. 1.42. What is the ratio of the Rent(as % of GDP) of Pakistan in 1992 to that in 1996?
Keep it short and to the point. 1.24. What is the ratio of the Rent(as % of GDP) in Equatorial Guinea in 1992 to that in 1998?
Your answer should be very brief. 0.08. What is the ratio of the Rent(as % of GDP) in Greece in 1992 to that in 1998?
Your answer should be compact. 4.42. What is the ratio of the Rent(as % of GDP) in Malaysia in 1992 to that in 1998?
Ensure brevity in your answer.  1.82. What is the ratio of the Rent(as % of GDP) in Pakistan in 1992 to that in 1998?
Offer a very short reply. 2.45. What is the ratio of the Rent(as % of GDP) in Equatorial Guinea in 1992 to that in 2007?
Ensure brevity in your answer.  0.08. What is the ratio of the Rent(as % of GDP) of Greece in 1992 to that in 2007?
Your answer should be very brief. 6.92. What is the ratio of the Rent(as % of GDP) in Malaysia in 1992 to that in 2007?
Your answer should be very brief. 0.78. What is the ratio of the Rent(as % of GDP) of Pakistan in 1992 to that in 2007?
Offer a very short reply. 0.66. What is the ratio of the Rent(as % of GDP) in Equatorial Guinea in 1993 to that in 1994?
Offer a very short reply. 0.71. What is the ratio of the Rent(as % of GDP) in Greece in 1993 to that in 1994?
Ensure brevity in your answer.  1.21. What is the ratio of the Rent(as % of GDP) in Malaysia in 1993 to that in 1994?
Make the answer very short. 1.17. What is the ratio of the Rent(as % of GDP) in Pakistan in 1993 to that in 1994?
Provide a succinct answer. 1.14. What is the ratio of the Rent(as % of GDP) of Equatorial Guinea in 1993 to that in 1995?
Your response must be concise. 0.91. What is the ratio of the Rent(as % of GDP) of Greece in 1993 to that in 1995?
Make the answer very short. 1.47. What is the ratio of the Rent(as % of GDP) of Malaysia in 1993 to that in 1995?
Your answer should be very brief. 1.19. What is the ratio of the Rent(as % of GDP) in Pakistan in 1993 to that in 1995?
Your answer should be very brief. 1.26. What is the ratio of the Rent(as % of GDP) of Equatorial Guinea in 1993 to that in 1996?
Provide a short and direct response. 0.36. What is the ratio of the Rent(as % of GDP) in Greece in 1993 to that in 1996?
Give a very brief answer. 1.41. What is the ratio of the Rent(as % of GDP) in Malaysia in 1993 to that in 1996?
Keep it short and to the point. 1.08. What is the ratio of the Rent(as % of GDP) in Pakistan in 1993 to that in 1996?
Ensure brevity in your answer.  0.99. What is the ratio of the Rent(as % of GDP) in Equatorial Guinea in 1993 to that in 1998?
Make the answer very short. 0.21. What is the ratio of the Rent(as % of GDP) of Greece in 1993 to that in 1998?
Your answer should be very brief. 3.34. What is the ratio of the Rent(as % of GDP) of Malaysia in 1993 to that in 1998?
Your answer should be very brief. 1.39. What is the ratio of the Rent(as % of GDP) in Pakistan in 1993 to that in 1998?
Offer a very short reply. 1.96. What is the ratio of the Rent(as % of GDP) in Equatorial Guinea in 1993 to that in 2007?
Offer a very short reply. 0.21. What is the ratio of the Rent(as % of GDP) of Greece in 1993 to that in 2007?
Ensure brevity in your answer.  5.23. What is the ratio of the Rent(as % of GDP) in Malaysia in 1993 to that in 2007?
Provide a short and direct response. 0.59. What is the ratio of the Rent(as % of GDP) of Pakistan in 1993 to that in 2007?
Provide a succinct answer. 0.53. What is the ratio of the Rent(as % of GDP) in Equatorial Guinea in 1994 to that in 1995?
Make the answer very short. 1.28. What is the ratio of the Rent(as % of GDP) in Greece in 1994 to that in 1995?
Your answer should be very brief. 1.21. What is the ratio of the Rent(as % of GDP) in Malaysia in 1994 to that in 1995?
Ensure brevity in your answer.  1.02. What is the ratio of the Rent(as % of GDP) in Pakistan in 1994 to that in 1995?
Your answer should be compact. 1.1. What is the ratio of the Rent(as % of GDP) in Equatorial Guinea in 1994 to that in 1996?
Provide a succinct answer. 0.5. What is the ratio of the Rent(as % of GDP) in Greece in 1994 to that in 1996?
Provide a short and direct response. 1.16. What is the ratio of the Rent(as % of GDP) in Malaysia in 1994 to that in 1996?
Offer a terse response. 0.92. What is the ratio of the Rent(as % of GDP) in Pakistan in 1994 to that in 1996?
Offer a terse response. 0.87. What is the ratio of the Rent(as % of GDP) in Equatorial Guinea in 1994 to that in 1998?
Keep it short and to the point. 0.3. What is the ratio of the Rent(as % of GDP) in Greece in 1994 to that in 1998?
Make the answer very short. 2.75. What is the ratio of the Rent(as % of GDP) in Malaysia in 1994 to that in 1998?
Your answer should be compact. 1.19. What is the ratio of the Rent(as % of GDP) in Pakistan in 1994 to that in 1998?
Provide a short and direct response. 1.72. What is the ratio of the Rent(as % of GDP) of Equatorial Guinea in 1994 to that in 2007?
Your response must be concise. 0.29. What is the ratio of the Rent(as % of GDP) in Greece in 1994 to that in 2007?
Ensure brevity in your answer.  4.3. What is the ratio of the Rent(as % of GDP) in Malaysia in 1994 to that in 2007?
Provide a short and direct response. 0.51. What is the ratio of the Rent(as % of GDP) in Pakistan in 1994 to that in 2007?
Provide a succinct answer. 0.46. What is the ratio of the Rent(as % of GDP) of Equatorial Guinea in 1995 to that in 1996?
Offer a terse response. 0.39. What is the ratio of the Rent(as % of GDP) in Greece in 1995 to that in 1996?
Your response must be concise. 0.96. What is the ratio of the Rent(as % of GDP) of Malaysia in 1995 to that in 1996?
Offer a very short reply. 0.91. What is the ratio of the Rent(as % of GDP) of Pakistan in 1995 to that in 1996?
Offer a terse response. 0.79. What is the ratio of the Rent(as % of GDP) of Equatorial Guinea in 1995 to that in 1998?
Offer a terse response. 0.23. What is the ratio of the Rent(as % of GDP) of Greece in 1995 to that in 1998?
Give a very brief answer. 2.27. What is the ratio of the Rent(as % of GDP) of Malaysia in 1995 to that in 1998?
Provide a succinct answer. 1.17. What is the ratio of the Rent(as % of GDP) of Pakistan in 1995 to that in 1998?
Provide a succinct answer. 1.56. What is the ratio of the Rent(as % of GDP) in Equatorial Guinea in 1995 to that in 2007?
Your answer should be compact. 0.23. What is the ratio of the Rent(as % of GDP) in Greece in 1995 to that in 2007?
Your response must be concise. 3.56. What is the ratio of the Rent(as % of GDP) in Malaysia in 1995 to that in 2007?
Offer a terse response. 0.5. What is the ratio of the Rent(as % of GDP) of Pakistan in 1995 to that in 2007?
Keep it short and to the point. 0.42. What is the ratio of the Rent(as % of GDP) in Equatorial Guinea in 1996 to that in 1998?
Your answer should be very brief. 0.6. What is the ratio of the Rent(as % of GDP) in Greece in 1996 to that in 1998?
Your answer should be compact. 2.36. What is the ratio of the Rent(as % of GDP) of Malaysia in 1996 to that in 1998?
Your answer should be compact. 1.29. What is the ratio of the Rent(as % of GDP) in Pakistan in 1996 to that in 1998?
Offer a terse response. 1.98. What is the ratio of the Rent(as % of GDP) of Equatorial Guinea in 1996 to that in 2007?
Your response must be concise. 0.59. What is the ratio of the Rent(as % of GDP) in Greece in 1996 to that in 2007?
Keep it short and to the point. 3.7. What is the ratio of the Rent(as % of GDP) of Malaysia in 1996 to that in 2007?
Keep it short and to the point. 0.55. What is the ratio of the Rent(as % of GDP) of Pakistan in 1996 to that in 2007?
Your response must be concise. 0.53. What is the ratio of the Rent(as % of GDP) in Equatorial Guinea in 1998 to that in 2007?
Provide a succinct answer. 0.99. What is the ratio of the Rent(as % of GDP) in Greece in 1998 to that in 2007?
Give a very brief answer. 1.57. What is the ratio of the Rent(as % of GDP) in Malaysia in 1998 to that in 2007?
Make the answer very short. 0.43. What is the ratio of the Rent(as % of GDP) of Pakistan in 1998 to that in 2007?
Give a very brief answer. 0.27. What is the difference between the highest and the second highest Rent(as % of GDP) in Equatorial Guinea?
Provide a short and direct response. 1.03. What is the difference between the highest and the second highest Rent(as % of GDP) in Greece?
Offer a very short reply. 0.01. What is the difference between the highest and the second highest Rent(as % of GDP) of Malaysia?
Your answer should be compact. 1.83. What is the difference between the highest and the second highest Rent(as % of GDP) in Pakistan?
Give a very brief answer. 0.35. What is the difference between the highest and the lowest Rent(as % of GDP) in Equatorial Guinea?
Offer a very short reply. 71.72. What is the difference between the highest and the lowest Rent(as % of GDP) of Greece?
Ensure brevity in your answer.  0.05. What is the difference between the highest and the lowest Rent(as % of GDP) in Malaysia?
Provide a short and direct response. 4.7. What is the difference between the highest and the lowest Rent(as % of GDP) of Pakistan?
Make the answer very short. 0.76. 